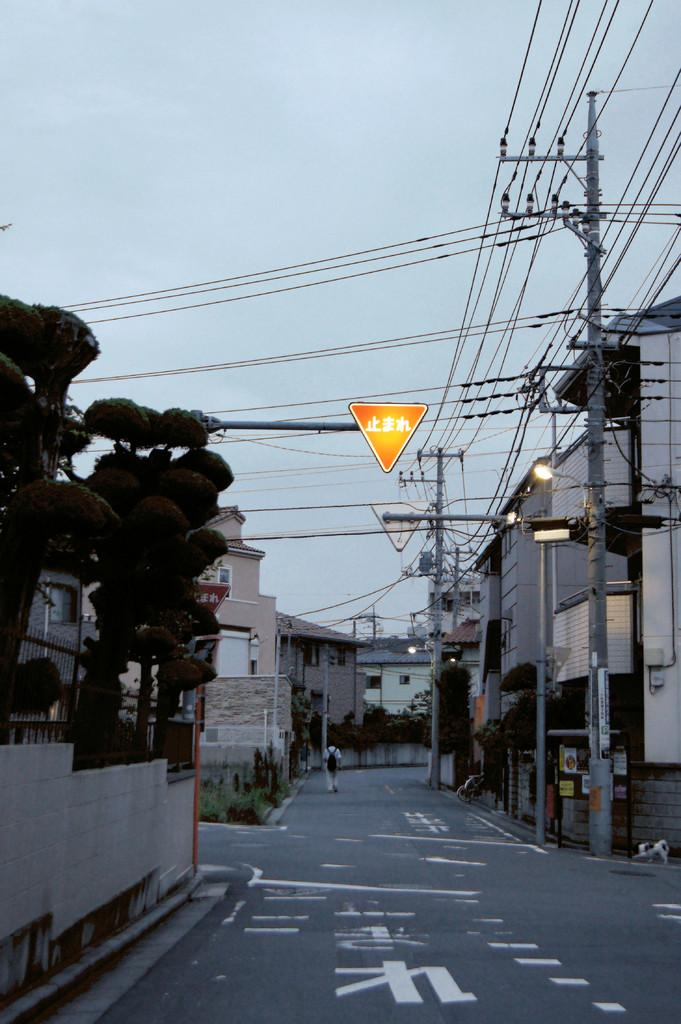Where was the image taken? The image was clicked outside. What structures can be seen in the image? There are buildings in the image. What type of vegetation is on the left side of the image? There are trees on the left side of the image. What is visible at the top of the image? The sky is visible at the top of the image. What is the desire of the cent in the image? There is no cent present in the image, so it is not possible to determine its desires. How does the image promote peace? The image itself does not promote peace, as it is a visual representation of an outdoor scene with buildings, trees, and sky. 